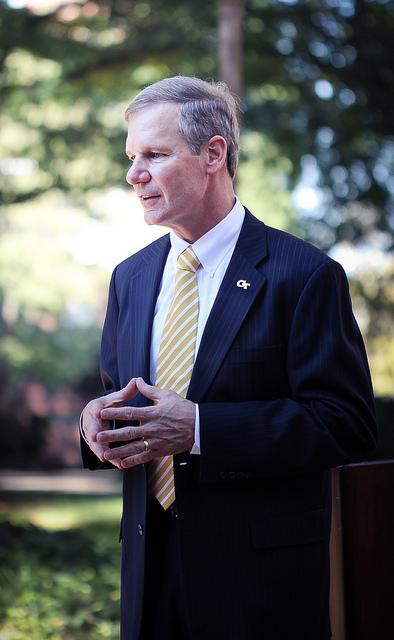What is on his lapel?
Answer briefly. Pin. Is the man wearing a wedding band?
Be succinct. Yes. What is the man looking at?
Quick response, please. Left. Is the elderly man wearing glasses?
Give a very brief answer. No. Why does the center man have gray hair?
Short answer required. Old. Is the man wearing a tie?
Write a very short answer. Yes. 